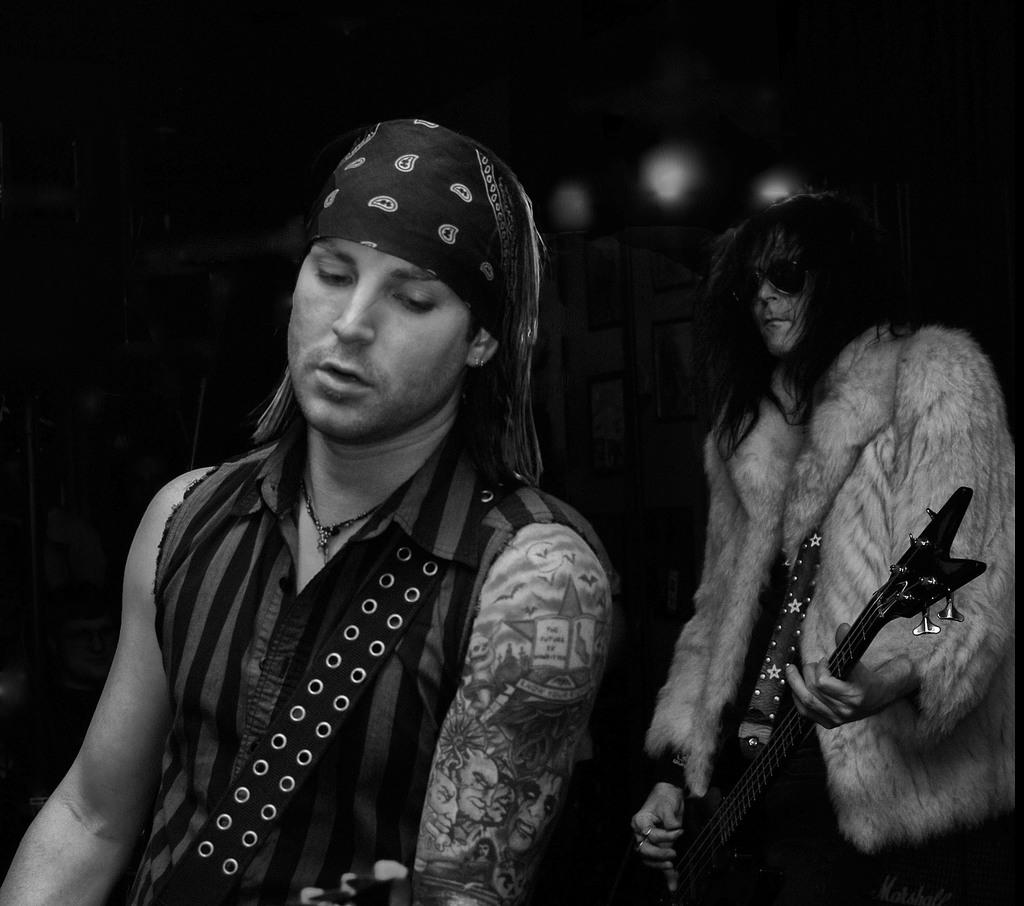How many people are in the image? There are two men in the image. What is one of the men holding? One of the men is holding a guitar. What type of theory is being discussed by the men in the image? There is no indication in the image that the men are discussing any theory. 